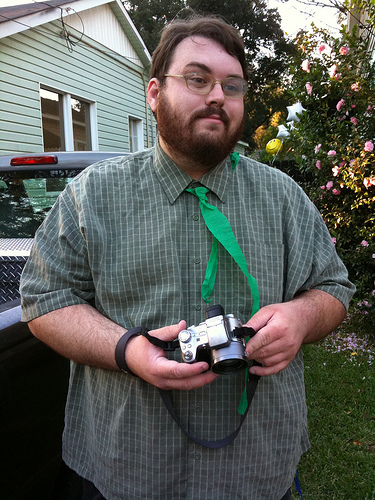What vehicle is it? It's a pickup truck, distinguishable by its cargo bed and cab structure. 